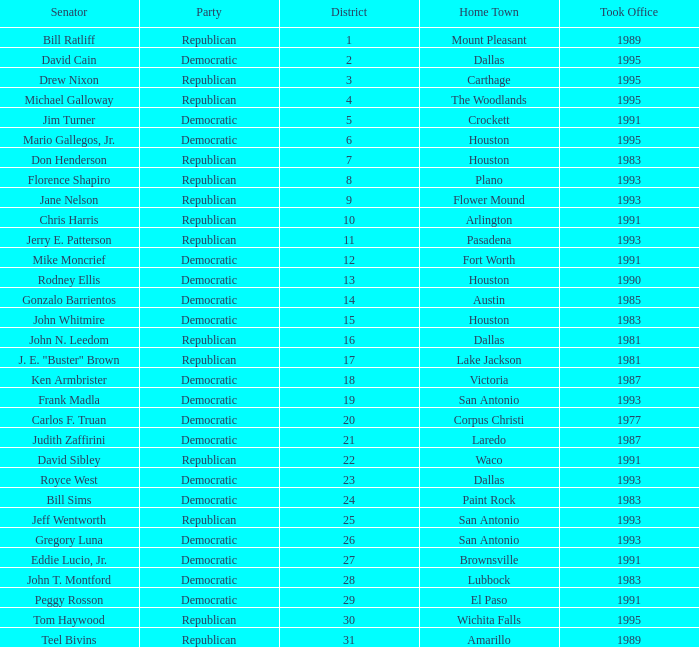What party took office after 1993 with Senator Michael Galloway? Republican. 